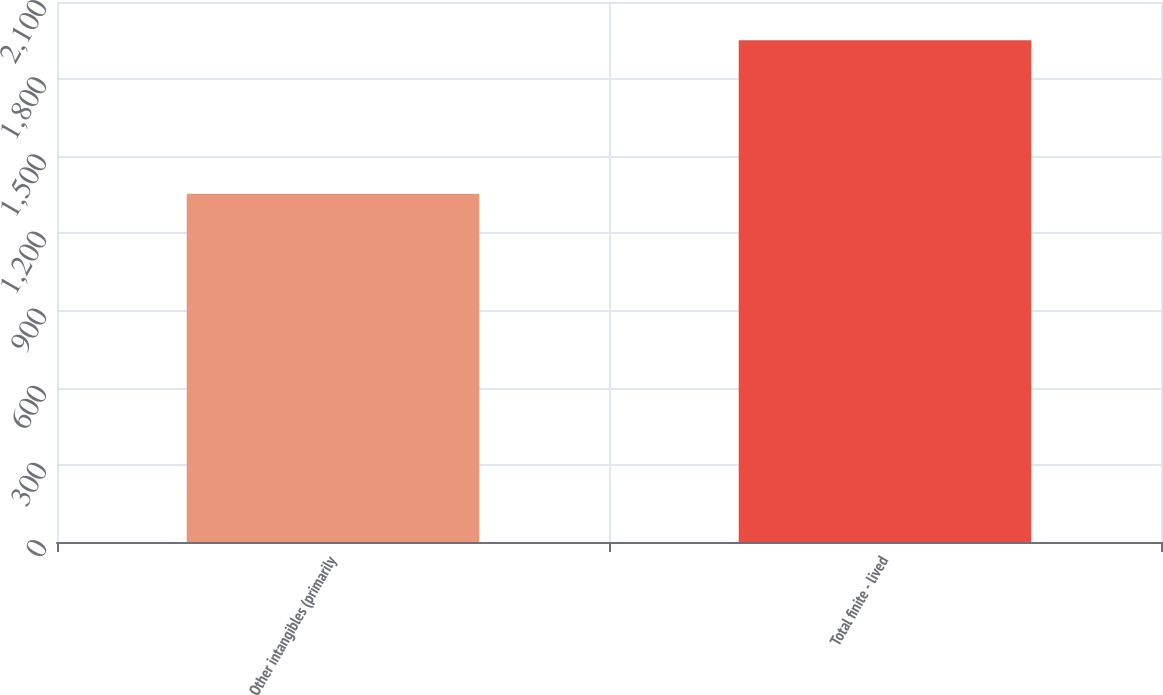<chart> <loc_0><loc_0><loc_500><loc_500><bar_chart><fcel>Other intangibles (primarily<fcel>Total finite - lived<nl><fcel>1354<fcel>1951<nl></chart> 